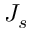<formula> <loc_0><loc_0><loc_500><loc_500>J _ { s }</formula> 